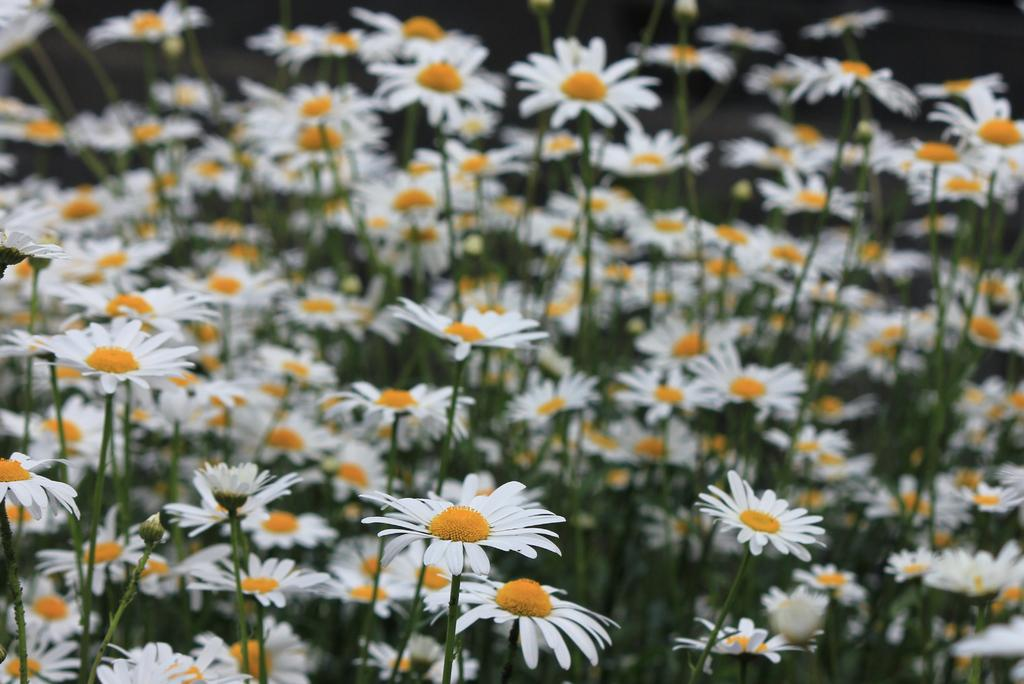What type of living organisms can be seen in the image? There are flowers and plants in the image. Can you describe the plants in the image? The plants in the image are not specified, but they are present alongside the flowers. What type of jelly can be seen in the image? There is no jelly present in the image; it only features flowers and plants. How does the destruction of the flowers and plants affect the knowledge gained from the image? The image does not depict the destruction of flowers and plants, and therefore, there is no impact on the knowledge gained from the image. 